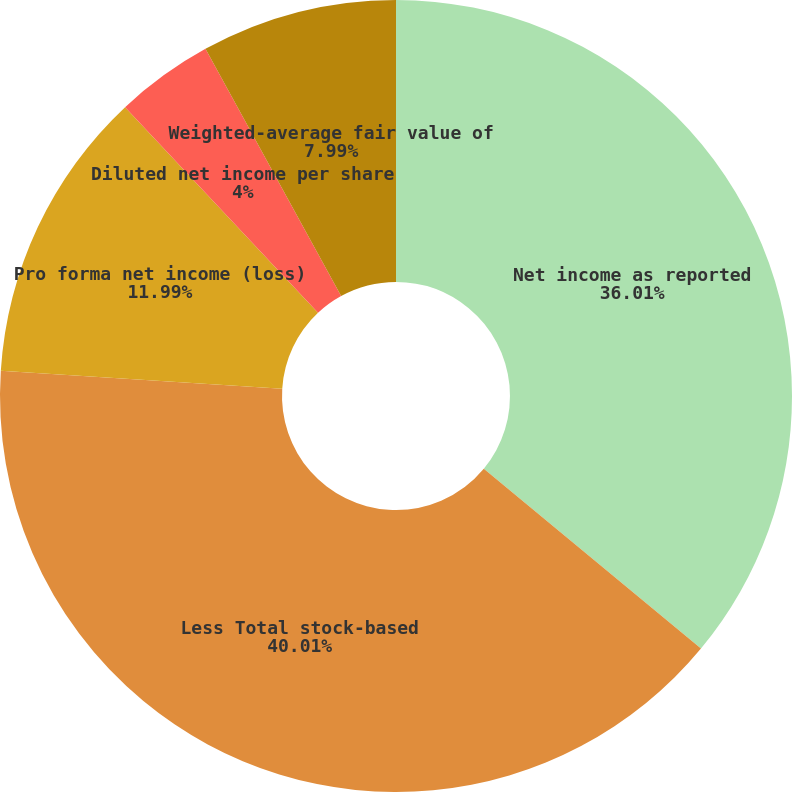Convert chart to OTSL. <chart><loc_0><loc_0><loc_500><loc_500><pie_chart><fcel>Net income as reported<fcel>Less Total stock-based<fcel>Pro forma net income (loss)<fcel>Diluted net income per share<fcel>Pro forma diluted net income<fcel>Weighted-average fair value of<nl><fcel>36.01%<fcel>40.01%<fcel>11.99%<fcel>4.0%<fcel>0.0%<fcel>7.99%<nl></chart> 